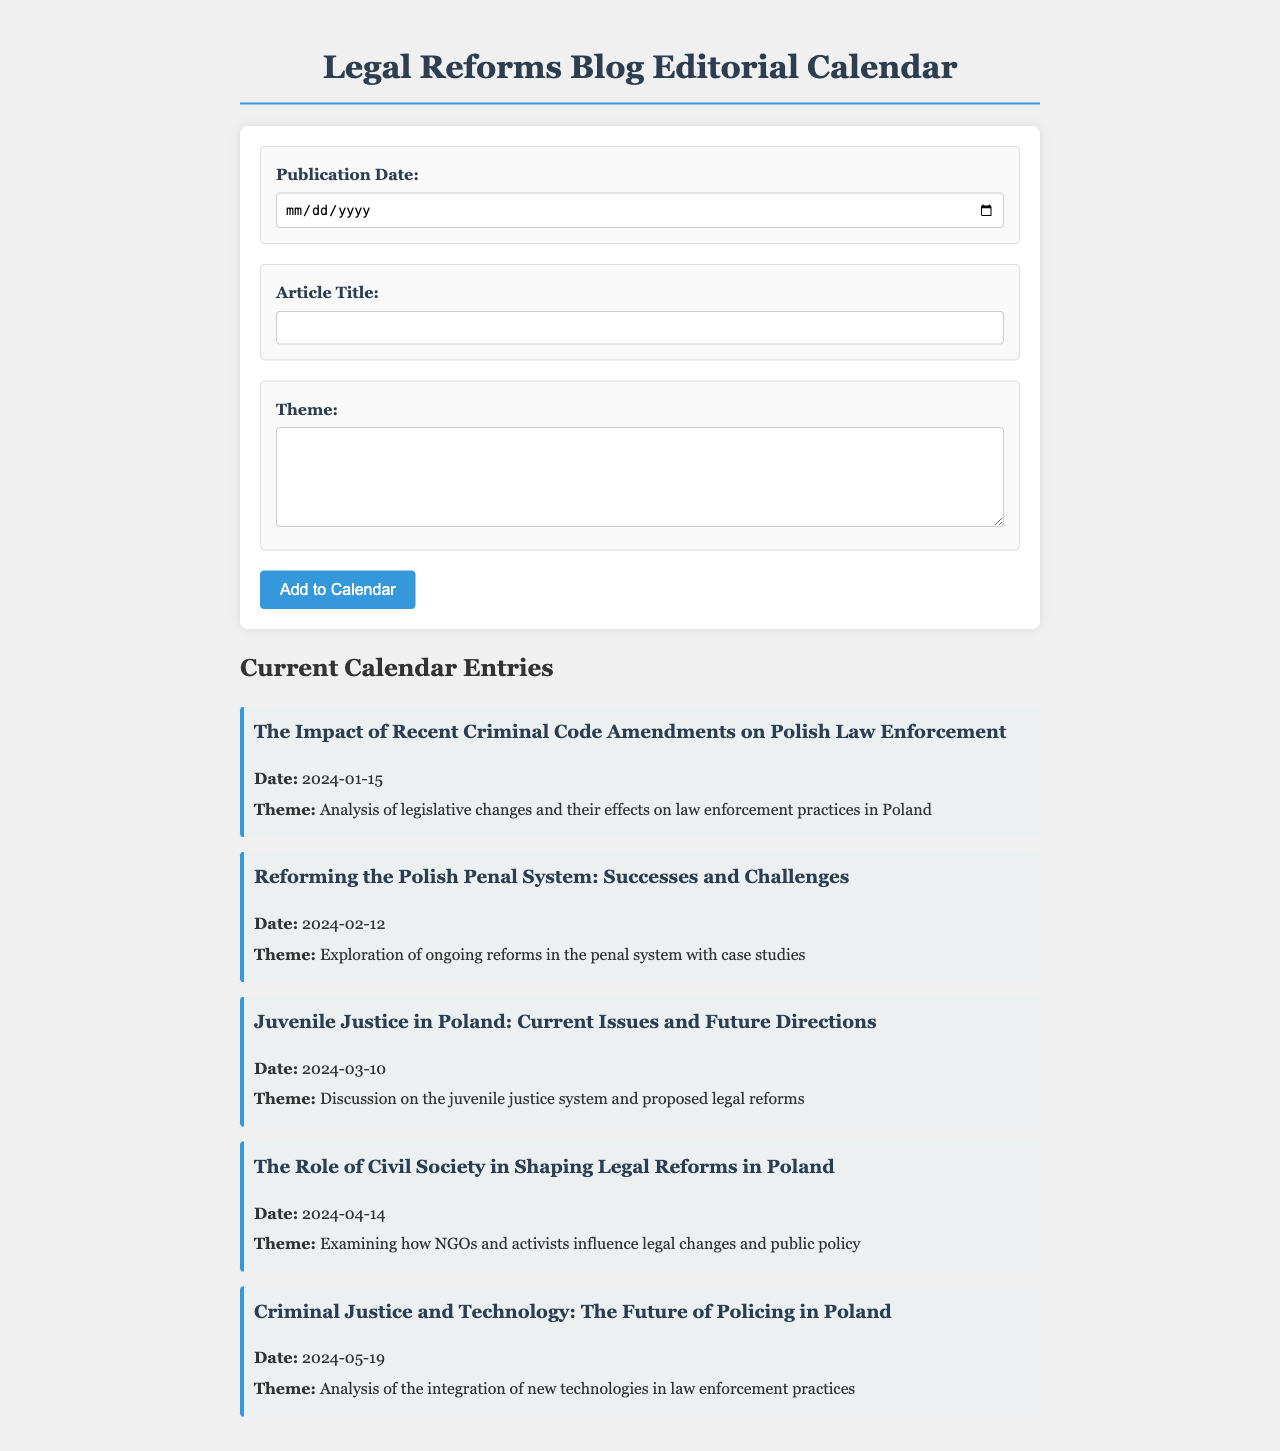what is the title of the first article? The title of the first article is the one listed under the first calendar entry, which provides the first topic discussed.
Answer: The Impact of Recent Criminal Code Amendments on Polish Law Enforcement what is the publication date of the article discussing Juvenile Justice? The publication date is specifically mentioned for each article, providing insights on when they will be published.
Answer: 2024-03-10 how many articles are currently listed in the calendar? The total number of articles is indicated by the number of calendar entry sections in the document.
Answer: 5 what is the theme of the article published on 2024-04-14? The theme is described in each calendar entry, detailing what the discussion or analysis focuses on for that specific date.
Answer: Examining how NGOs and activists influence legal changes and public policy which article analyzes the integration of new technologies in law enforcement? This inquiry requires locating the specific article that deals with technology's role in policing.
Answer: Criminal Justice and Technology: The Future of Policing in Poland what is the overall focus of the February article? The overall focus is derived from the theme provided for that specific article, giving an insight into what it covers.
Answer: Exploration of ongoing reforms in the penal system with case studies how is the blog’s editorial calendar structured? The structure is answered by describing the components that make up the editorial calendar, as evident in the document layout.
Answer: Each entry includes a title, date, and theme 